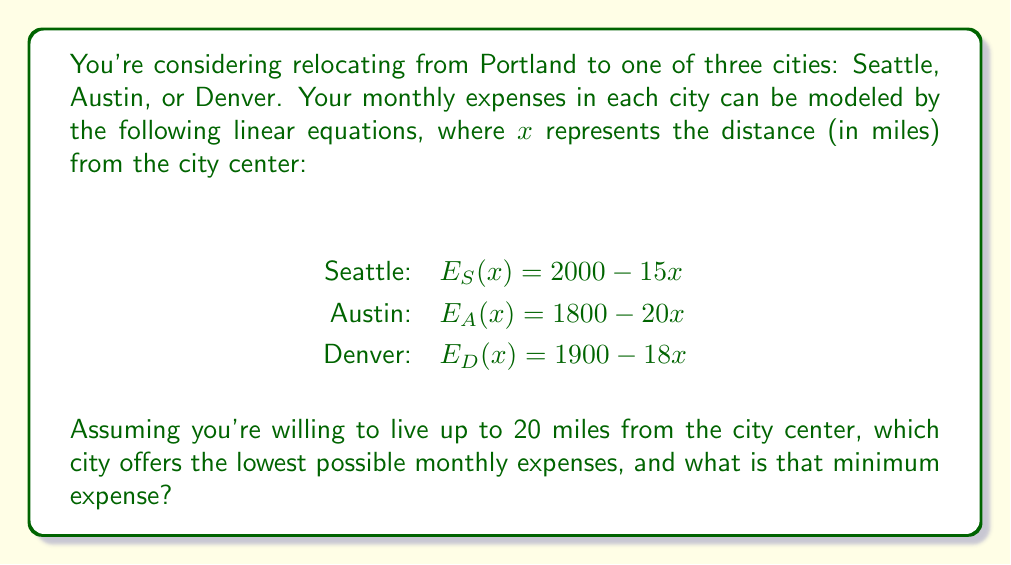Show me your answer to this math problem. To solve this optimization problem, we need to find the minimum value for each city's expense function within the given constraint of 0 ≤ x ≤ 20.

1. For Seattle: $E_S(x) = 2000 - 15x$
   The function is linear and decreasing, so the minimum will occur at x = 20.
   $E_S(20) = 2000 - 15(20) = 1700$

2. For Austin: $E_A(x) = 1800 - 20x$
   Again, the function is linear and decreasing, so the minimum will occur at x = 20.
   $E_A(20) = 1800 - 20(20) = 1400$

3. For Denver: $E_D(x) = 1900 - 18x$
   Once more, the function is linear and decreasing, so the minimum will occur at x = 20.
   $E_D(20) = 1900 - 18(20) = 1540$

Comparing the minimum expenses:
Austin: $1400
Denver: $1540
Seattle: $1700

Therefore, Austin offers the lowest possible monthly expenses at $1400.
Answer: Austin offers the lowest possible monthly expenses at $1400. 